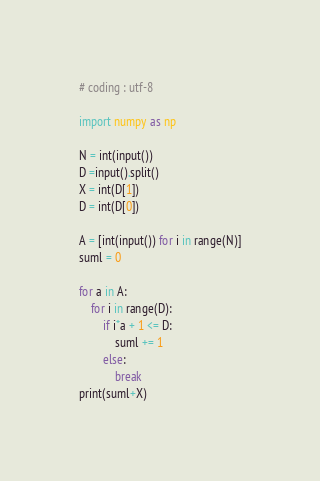<code> <loc_0><loc_0><loc_500><loc_500><_Python_># coding : utf-8

import numpy as np

N = int(input())
D =input().split()
X = int(D[1])
D = int(D[0])

A = [int(input()) for i in range(N)]
suml = 0

for a in A:
    for i in range(D):
        if i*a + 1 <= D:
            suml += 1
        else:
            break
print(suml+X)
</code> 